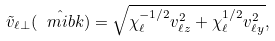Convert formula to latex. <formula><loc_0><loc_0><loc_500><loc_500>\tilde { v } _ { \ell \perp } ( \hat { \ m i b k } ) = \sqrt { \chi _ { \ell } ^ { - 1 / 2 } v _ { \ell z } ^ { 2 } + \chi _ { \ell } ^ { 1 / 2 } v _ { \ell y } ^ { 2 } } ,</formula> 